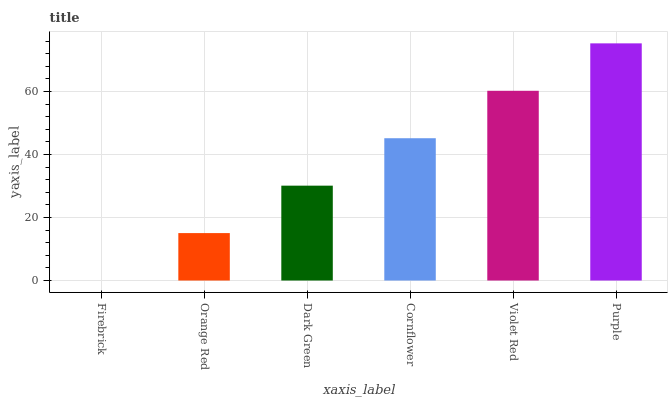Is Firebrick the minimum?
Answer yes or no. Yes. Is Purple the maximum?
Answer yes or no. Yes. Is Orange Red the minimum?
Answer yes or no. No. Is Orange Red the maximum?
Answer yes or no. No. Is Orange Red greater than Firebrick?
Answer yes or no. Yes. Is Firebrick less than Orange Red?
Answer yes or no. Yes. Is Firebrick greater than Orange Red?
Answer yes or no. No. Is Orange Red less than Firebrick?
Answer yes or no. No. Is Cornflower the high median?
Answer yes or no. Yes. Is Dark Green the low median?
Answer yes or no. Yes. Is Orange Red the high median?
Answer yes or no. No. Is Orange Red the low median?
Answer yes or no. No. 